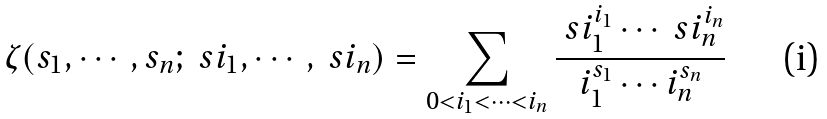<formula> <loc_0><loc_0><loc_500><loc_500>\zeta ( s _ { 1 } , \cdots , s _ { n } ; \ s i _ { 1 } , \cdots , \ s i _ { n } ) = \sum _ { 0 < i _ { 1 } < \cdots < i _ { n } } \frac { \ s i _ { 1 } ^ { i _ { 1 } } \cdots \ s i _ { n } ^ { i _ { n } } } { i _ { 1 } ^ { s _ { 1 } } \cdots i _ { n } ^ { s _ { n } } }</formula> 